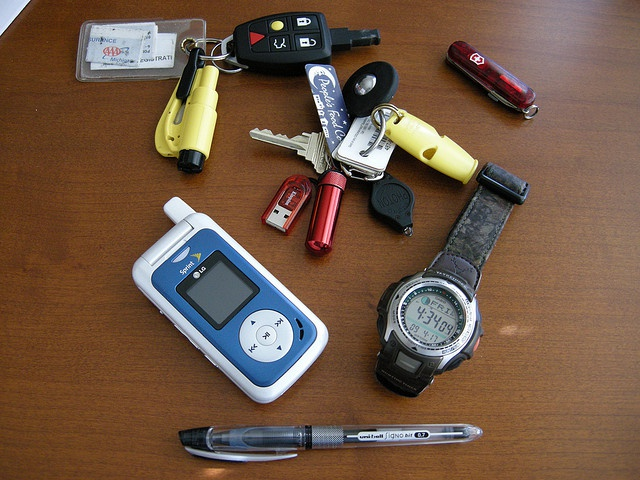Describe the objects in this image and their specific colors. I can see cell phone in lightblue, lightgray, blue, gray, and black tones and knife in lightblue, black, maroon, gray, and darkgray tones in this image. 